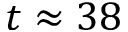Convert formula to latex. <formula><loc_0><loc_0><loc_500><loc_500>t \approx 3 8</formula> 